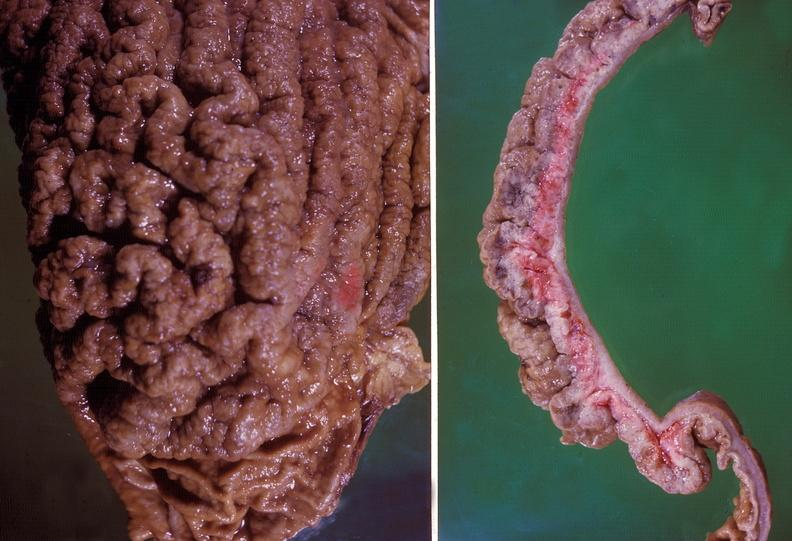s spina bifida present?
Answer the question using a single word or phrase. No 